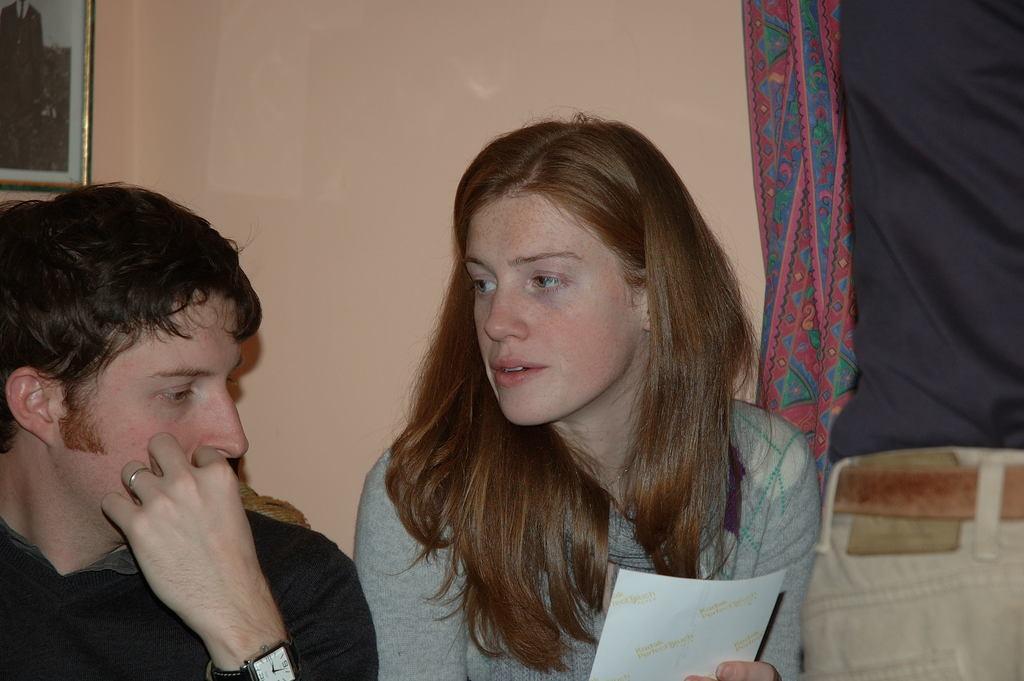Can you describe this image briefly? In this image I can see a man, a woman and I can see she is holding a white colour thing. I can also see something is written on it. On the left side of the image I can see he is wearing a watch. On the right side of the image I can see a colourful cloth and on the top left side of the image I can see a frame on the wall. 